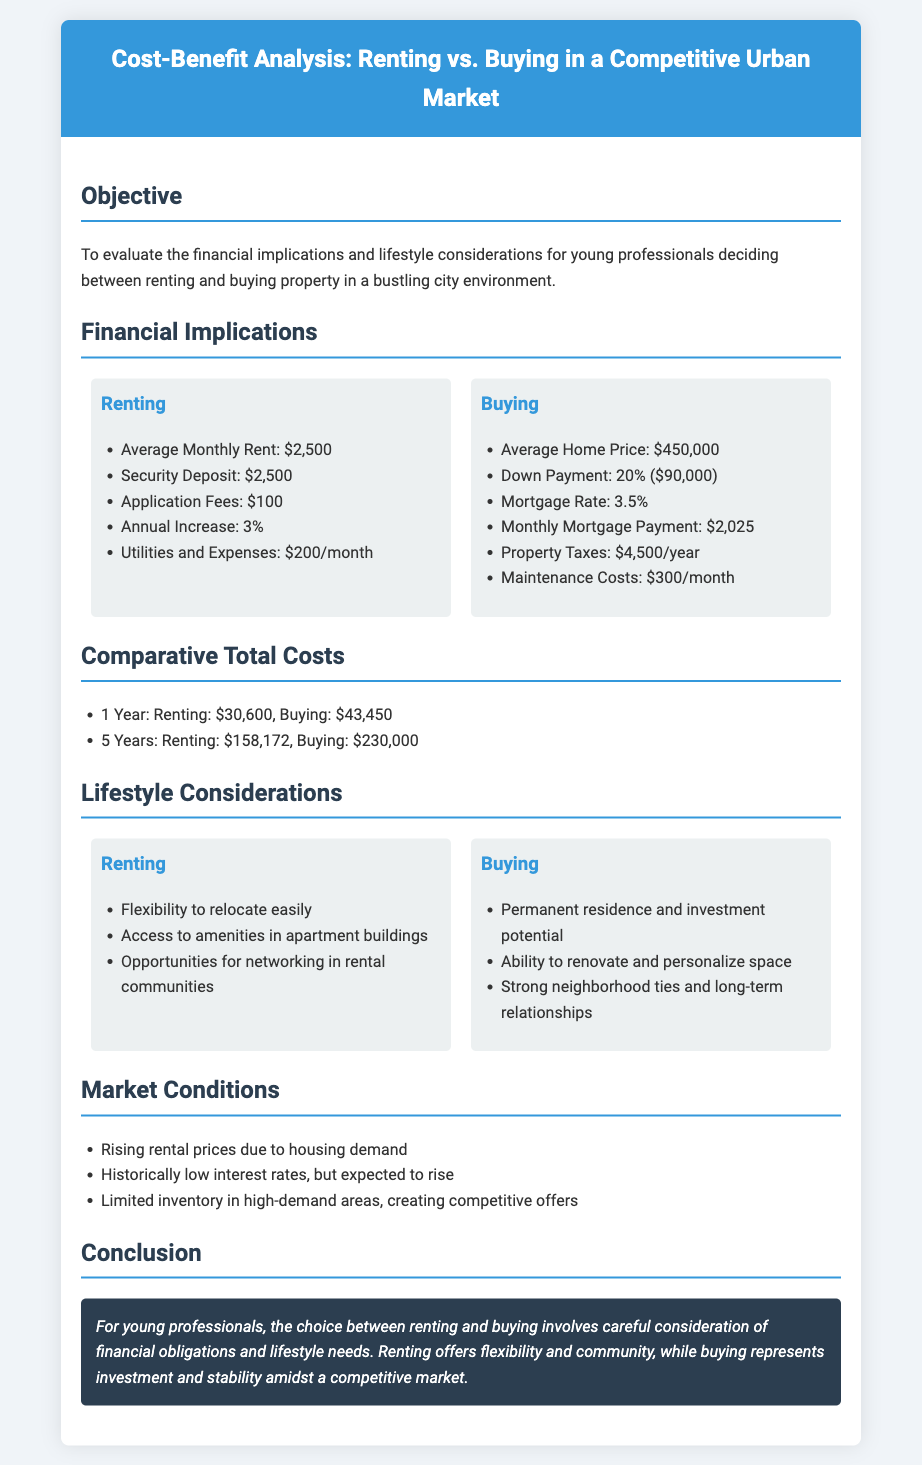what is the average monthly rent? The average monthly rent listed in the document is $2,500.
Answer: $2,500 what is the average home price? The average home price mentioned in the document is $450,000.
Answer: $450,000 how much is the down payment for buying? The down payment for buying is specified as 20% which amounts to $90,000.
Answer: $90,000 what are the total costs of renting for 5 years? The total costs of renting for 5 years is reported as $158,172.
Answer: $158,172 what is one advantage of renting? An advantage of renting mentioned in the document is flexibility to relocate easily.
Answer: flexibility to relocate easily what is one lifestyle benefit of buying? A lifestyle benefit of buying is the ability to renovate and personalize space.
Answer: ability to renovate and personalize space how much are property taxes per year? The property taxes per year for buying is stated as $4,500.
Answer: $4,500 what trend is noted in the market conditions regarding rental prices? The trend regarding rental prices indicates they are rising due to housing demand.
Answer: rising rental prices what is the annual increase in renting costs? The annual increase in renting costs is noted as 3%.
Answer: 3% what does the conclusion suggest about the choice between renting and buying? The conclusion suggests that the choice involves careful consideration of financial obligations and lifestyle needs.
Answer: careful consideration of financial obligations and lifestyle needs 